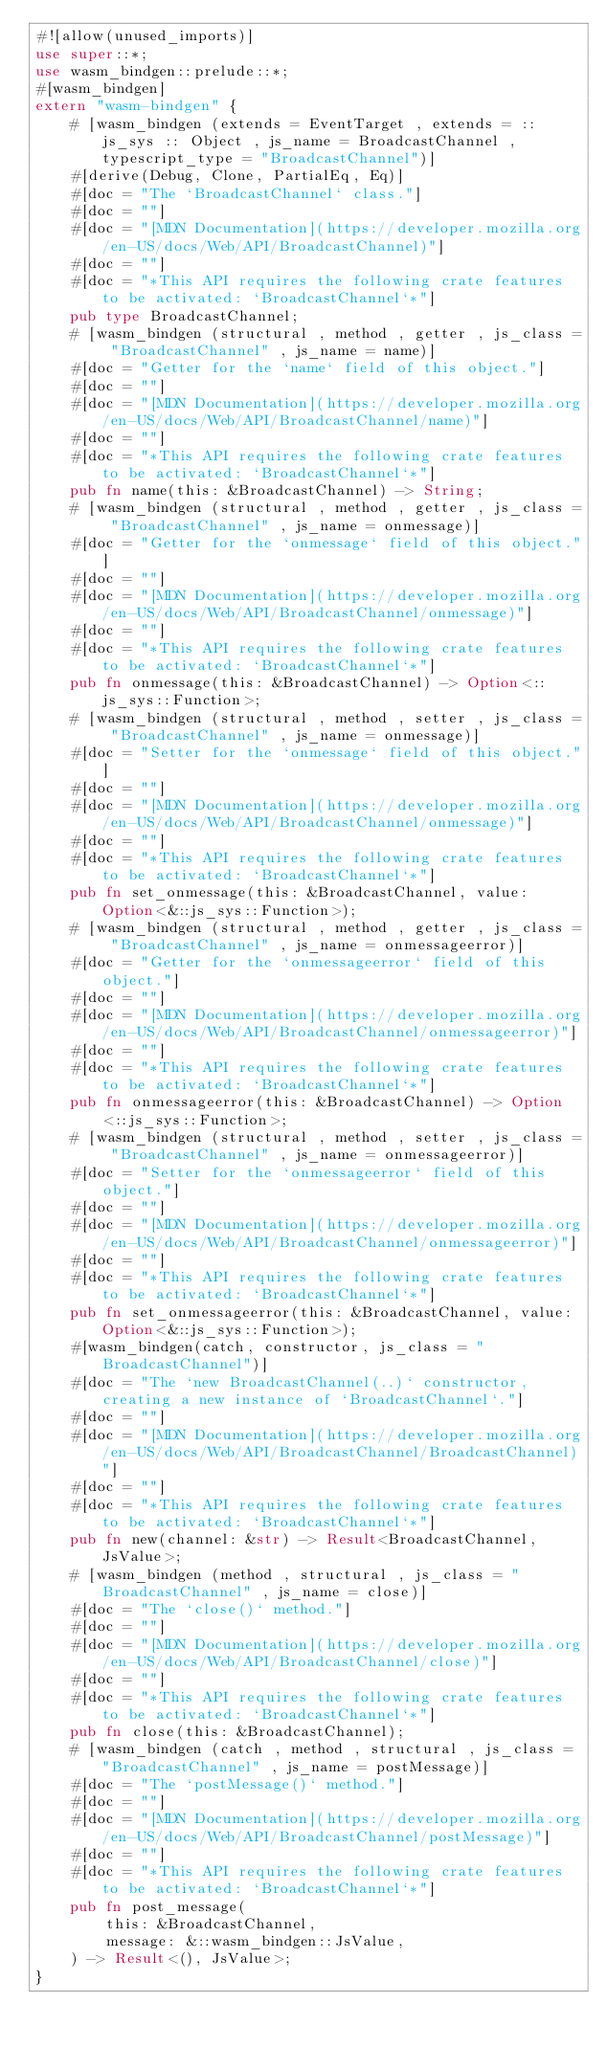Convert code to text. <code><loc_0><loc_0><loc_500><loc_500><_Rust_>#![allow(unused_imports)]
use super::*;
use wasm_bindgen::prelude::*;
#[wasm_bindgen]
extern "wasm-bindgen" {
    # [wasm_bindgen (extends = EventTarget , extends = :: js_sys :: Object , js_name = BroadcastChannel , typescript_type = "BroadcastChannel")]
    #[derive(Debug, Clone, PartialEq, Eq)]
    #[doc = "The `BroadcastChannel` class."]
    #[doc = ""]
    #[doc = "[MDN Documentation](https://developer.mozilla.org/en-US/docs/Web/API/BroadcastChannel)"]
    #[doc = ""]
    #[doc = "*This API requires the following crate features to be activated: `BroadcastChannel`*"]
    pub type BroadcastChannel;
    # [wasm_bindgen (structural , method , getter , js_class = "BroadcastChannel" , js_name = name)]
    #[doc = "Getter for the `name` field of this object."]
    #[doc = ""]
    #[doc = "[MDN Documentation](https://developer.mozilla.org/en-US/docs/Web/API/BroadcastChannel/name)"]
    #[doc = ""]
    #[doc = "*This API requires the following crate features to be activated: `BroadcastChannel`*"]
    pub fn name(this: &BroadcastChannel) -> String;
    # [wasm_bindgen (structural , method , getter , js_class = "BroadcastChannel" , js_name = onmessage)]
    #[doc = "Getter for the `onmessage` field of this object."]
    #[doc = ""]
    #[doc = "[MDN Documentation](https://developer.mozilla.org/en-US/docs/Web/API/BroadcastChannel/onmessage)"]
    #[doc = ""]
    #[doc = "*This API requires the following crate features to be activated: `BroadcastChannel`*"]
    pub fn onmessage(this: &BroadcastChannel) -> Option<::js_sys::Function>;
    # [wasm_bindgen (structural , method , setter , js_class = "BroadcastChannel" , js_name = onmessage)]
    #[doc = "Setter for the `onmessage` field of this object."]
    #[doc = ""]
    #[doc = "[MDN Documentation](https://developer.mozilla.org/en-US/docs/Web/API/BroadcastChannel/onmessage)"]
    #[doc = ""]
    #[doc = "*This API requires the following crate features to be activated: `BroadcastChannel`*"]
    pub fn set_onmessage(this: &BroadcastChannel, value: Option<&::js_sys::Function>);
    # [wasm_bindgen (structural , method , getter , js_class = "BroadcastChannel" , js_name = onmessageerror)]
    #[doc = "Getter for the `onmessageerror` field of this object."]
    #[doc = ""]
    #[doc = "[MDN Documentation](https://developer.mozilla.org/en-US/docs/Web/API/BroadcastChannel/onmessageerror)"]
    #[doc = ""]
    #[doc = "*This API requires the following crate features to be activated: `BroadcastChannel`*"]
    pub fn onmessageerror(this: &BroadcastChannel) -> Option<::js_sys::Function>;
    # [wasm_bindgen (structural , method , setter , js_class = "BroadcastChannel" , js_name = onmessageerror)]
    #[doc = "Setter for the `onmessageerror` field of this object."]
    #[doc = ""]
    #[doc = "[MDN Documentation](https://developer.mozilla.org/en-US/docs/Web/API/BroadcastChannel/onmessageerror)"]
    #[doc = ""]
    #[doc = "*This API requires the following crate features to be activated: `BroadcastChannel`*"]
    pub fn set_onmessageerror(this: &BroadcastChannel, value: Option<&::js_sys::Function>);
    #[wasm_bindgen(catch, constructor, js_class = "BroadcastChannel")]
    #[doc = "The `new BroadcastChannel(..)` constructor, creating a new instance of `BroadcastChannel`."]
    #[doc = ""]
    #[doc = "[MDN Documentation](https://developer.mozilla.org/en-US/docs/Web/API/BroadcastChannel/BroadcastChannel)"]
    #[doc = ""]
    #[doc = "*This API requires the following crate features to be activated: `BroadcastChannel`*"]
    pub fn new(channel: &str) -> Result<BroadcastChannel, JsValue>;
    # [wasm_bindgen (method , structural , js_class = "BroadcastChannel" , js_name = close)]
    #[doc = "The `close()` method."]
    #[doc = ""]
    #[doc = "[MDN Documentation](https://developer.mozilla.org/en-US/docs/Web/API/BroadcastChannel/close)"]
    #[doc = ""]
    #[doc = "*This API requires the following crate features to be activated: `BroadcastChannel`*"]
    pub fn close(this: &BroadcastChannel);
    # [wasm_bindgen (catch , method , structural , js_class = "BroadcastChannel" , js_name = postMessage)]
    #[doc = "The `postMessage()` method."]
    #[doc = ""]
    #[doc = "[MDN Documentation](https://developer.mozilla.org/en-US/docs/Web/API/BroadcastChannel/postMessage)"]
    #[doc = ""]
    #[doc = "*This API requires the following crate features to be activated: `BroadcastChannel`*"]
    pub fn post_message(
        this: &BroadcastChannel,
        message: &::wasm_bindgen::JsValue,
    ) -> Result<(), JsValue>;
}
</code> 